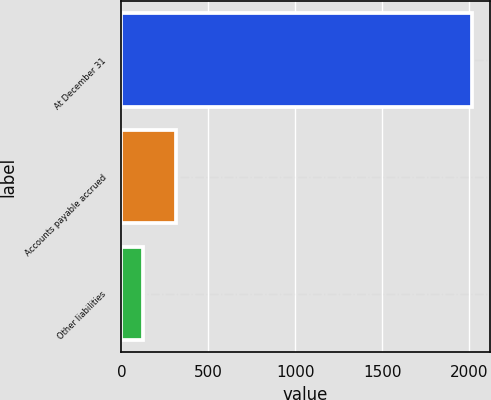<chart> <loc_0><loc_0><loc_500><loc_500><bar_chart><fcel>At December 31<fcel>Accounts payable accrued<fcel>Other liabilities<nl><fcel>2017<fcel>312.22<fcel>122.8<nl></chart> 